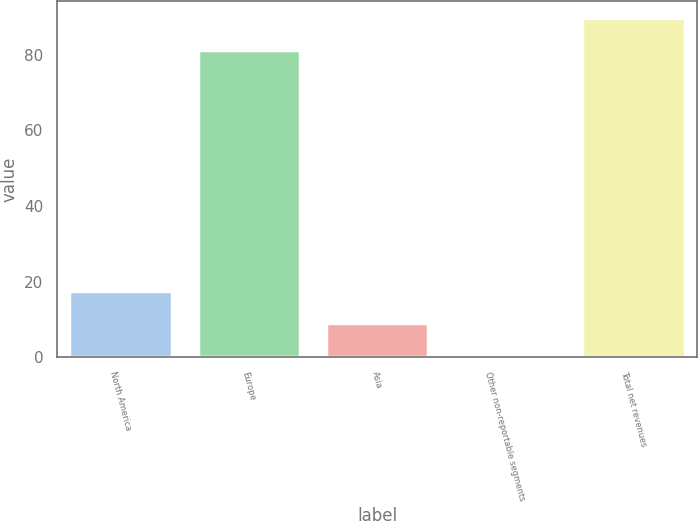<chart> <loc_0><loc_0><loc_500><loc_500><bar_chart><fcel>North America<fcel>Europe<fcel>Asia<fcel>Other non-reportable segments<fcel>Total net revenues<nl><fcel>17.62<fcel>81.2<fcel>9.01<fcel>0.4<fcel>89.81<nl></chart> 